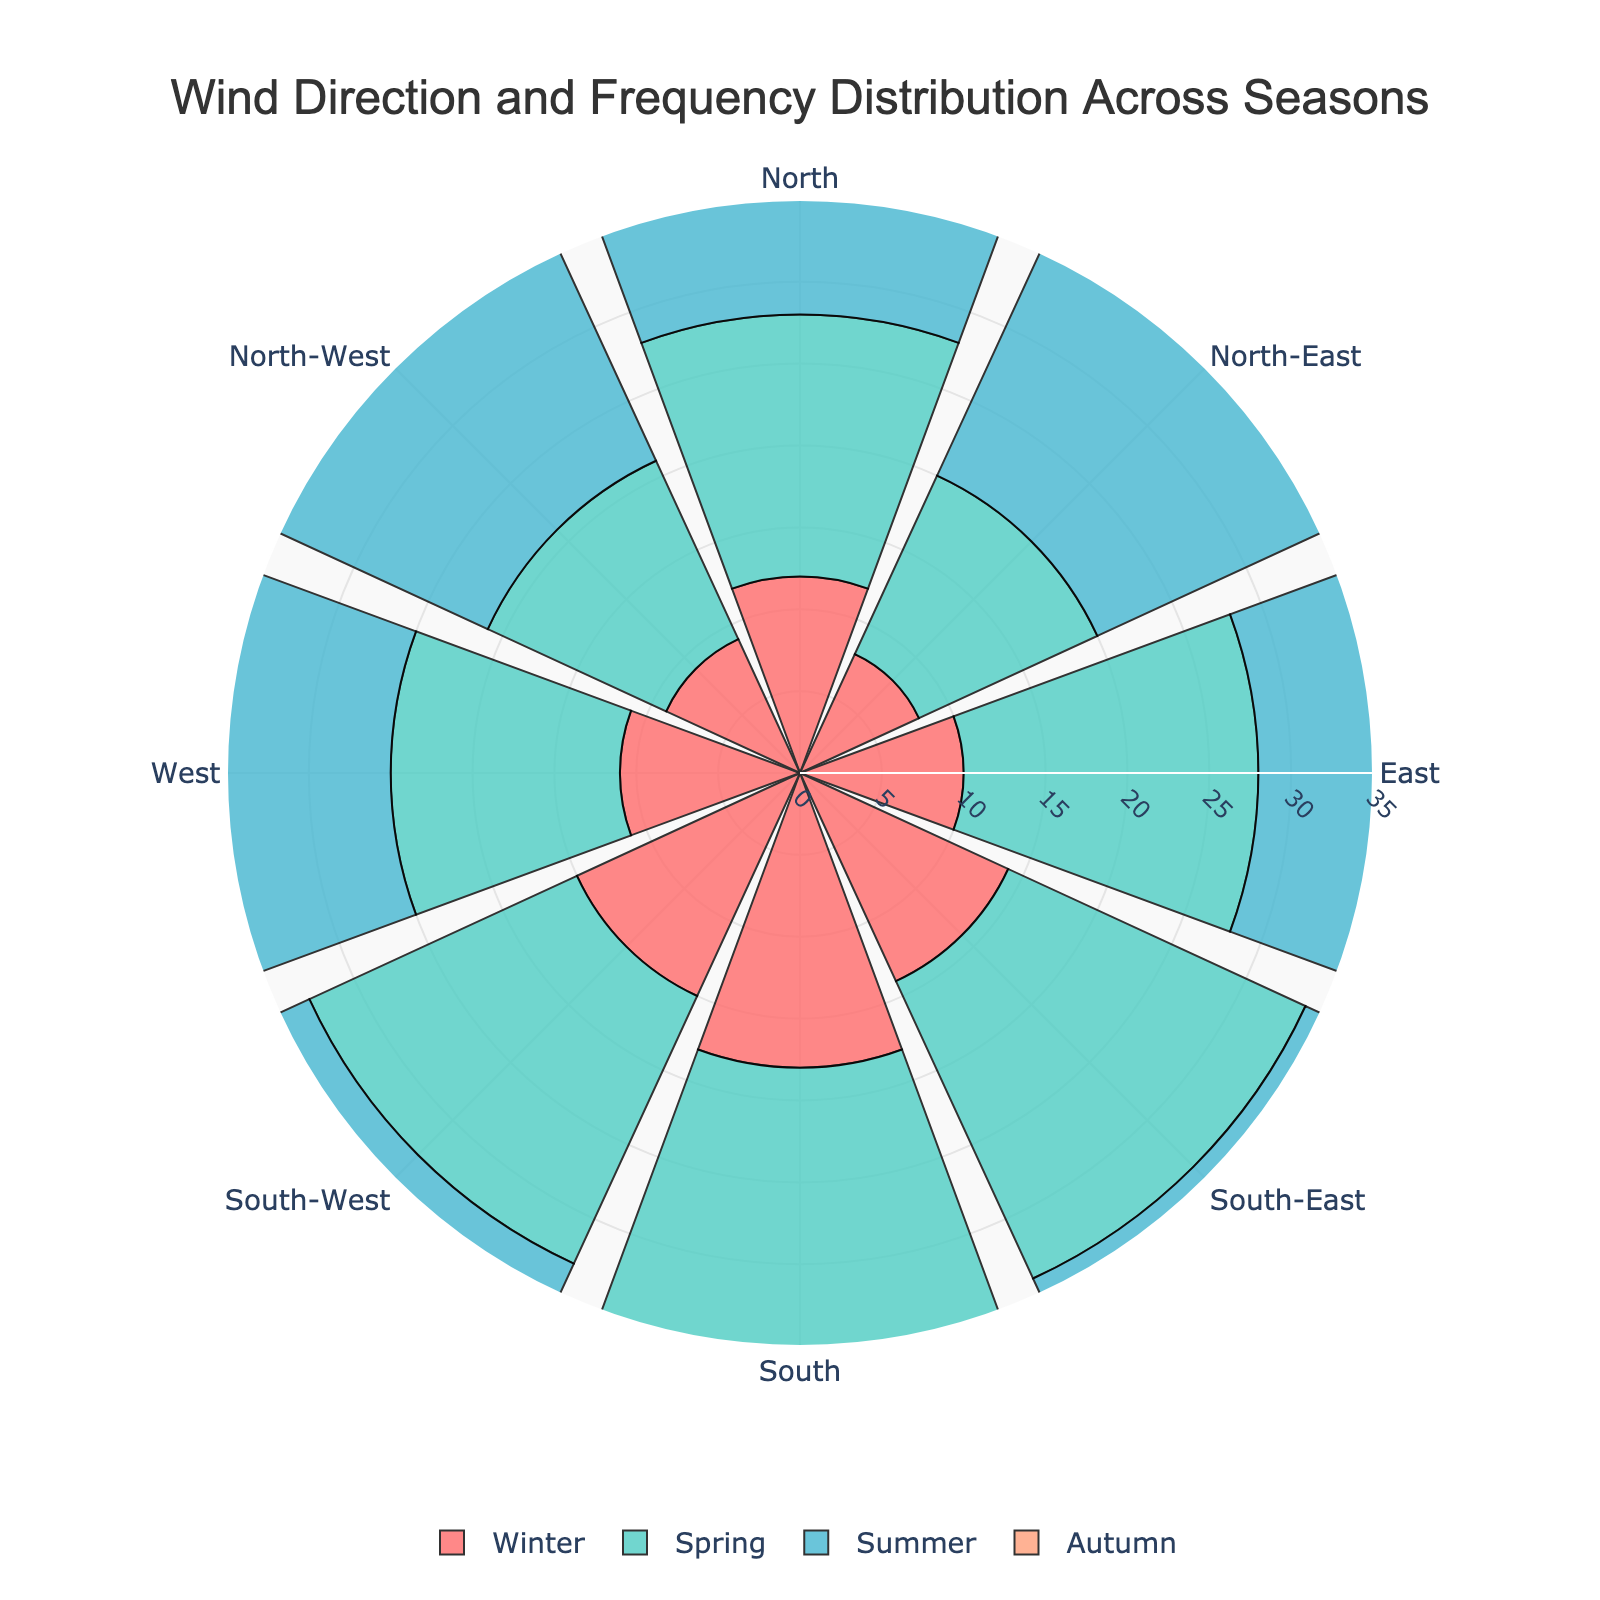What is the title of the rose chart? The title is typically displayed at the top of the figure, centered in this case. Its purpose is to describe the content of the chart.
Answer: Wind Direction and Frequency Distribution Across Seasons In which season is the wind frequency from the South the highest? By examining the rose chart, you can compare the radial lengths corresponding to the South direction across different seasons. Look for the longest radial line in the South direction.
Answer: Summer Which season has the lowest wind frequency from the North-West direction? Compare the radial lengths for the North-West direction across all four seasons to identify the shortest one.
Answer: Winter What is the average wind frequency from the East across all seasons? Sum up the frequencies from the East direction for all seasons and then divide by the number of seasons: (10 + 18 + 24 + 15) / 4 = 67 / 4.
Answer: 16.75 Which direction shows the most consistent wind frequencies across all seasons? Examine the chart and identify the direction where the radial lengths have the least variation among all four seasons.
Answer: South-West Which season exhibits the highest overall wind frequency across all directions? Sum the frequencies for each direction in every season and compare the totals.
Answer: Summer How does the frequency of North-East wind in Spring compare to that in Autumn? Compare the radial lengths for the North-East direction in Spring and Autumn. Spring's frequency is 12, and Autumn's is 10.
Answer: Spring has a higher frequency What are the distinct colors used to represent each season? Each season is represented by a unique color, which can be identified from the legend of the chart.
Answer: Red, Teal, Blue, Light Salmon What is the range of wind frequencies displayed on the radial axis? Check the radial axis to determine the minimum and maximum frequency values plotted.
Answer: 0 to 35 What is the difference in the wind frequency from the South-West between Winter and Spring? Subtract the frequency of South-West wind in Winter from that in Spring: 18 - 15 = 3.
Answer: 3 